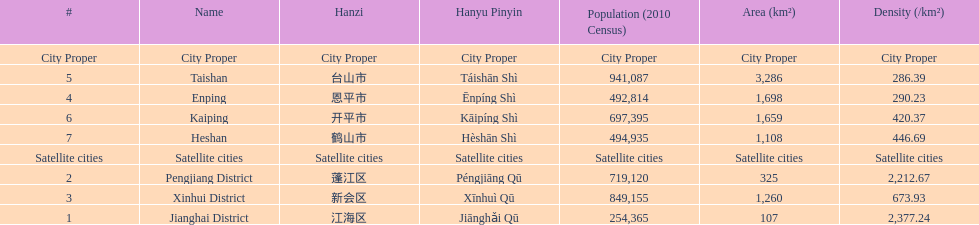Is enping more/less dense than kaiping? Less. 